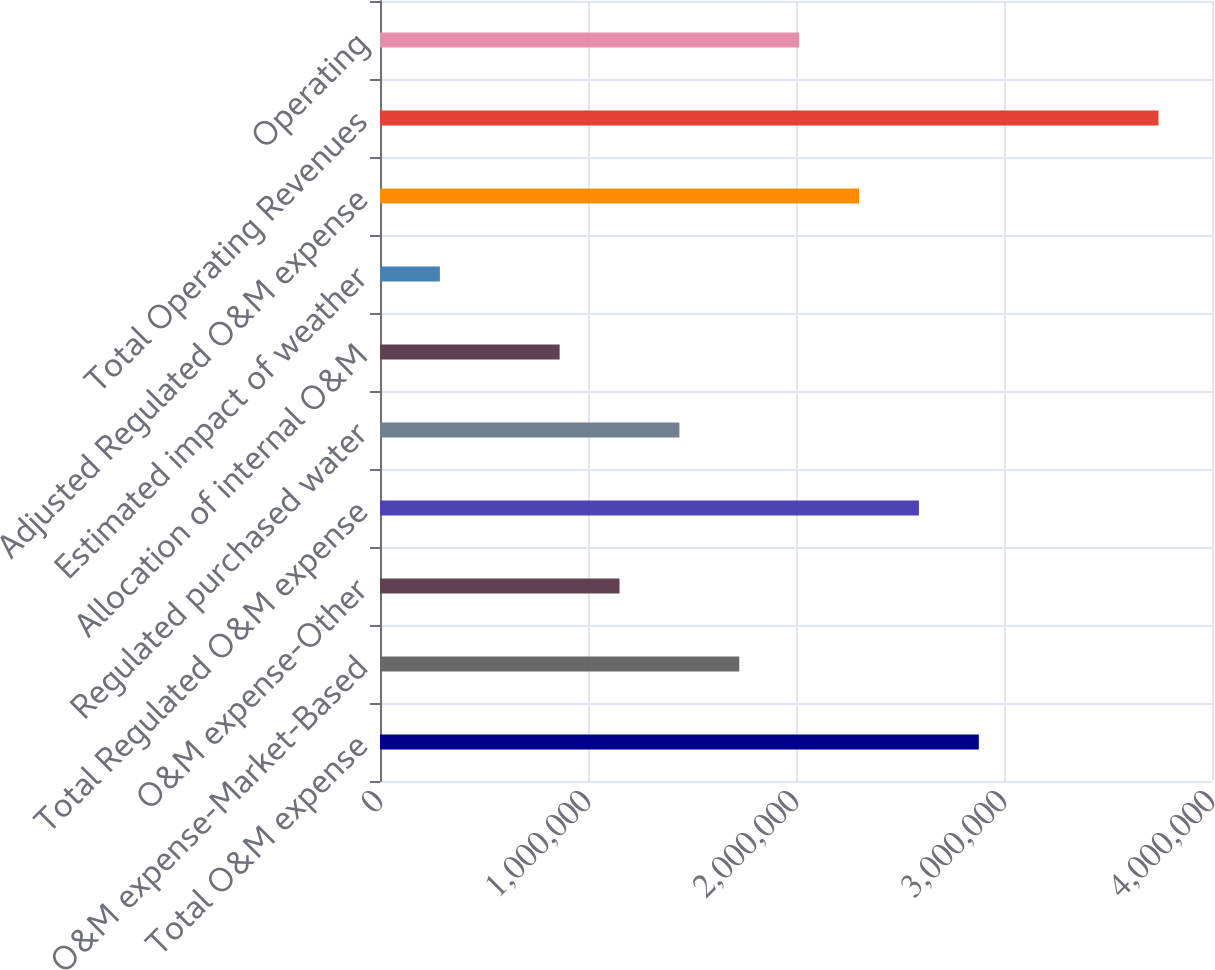Convert chart to OTSL. <chart><loc_0><loc_0><loc_500><loc_500><bar_chart><fcel>Total O&M expense<fcel>O&M expense-Market-Based<fcel>O&M expense-Other<fcel>Total Regulated O&M expense<fcel>Regulated purchased water<fcel>Allocation of internal O&M<fcel>Estimated impact of weather<fcel>Adjusted Regulated O&M expense<fcel>Total Operating Revenues<fcel>Operating<nl><fcel>2.87894e+06<fcel>1.72738e+06<fcel>1.1516e+06<fcel>2.59105e+06<fcel>1.43949e+06<fcel>863708<fcel>287928<fcel>2.30316e+06<fcel>3.74261e+06<fcel>2.01527e+06<nl></chart> 